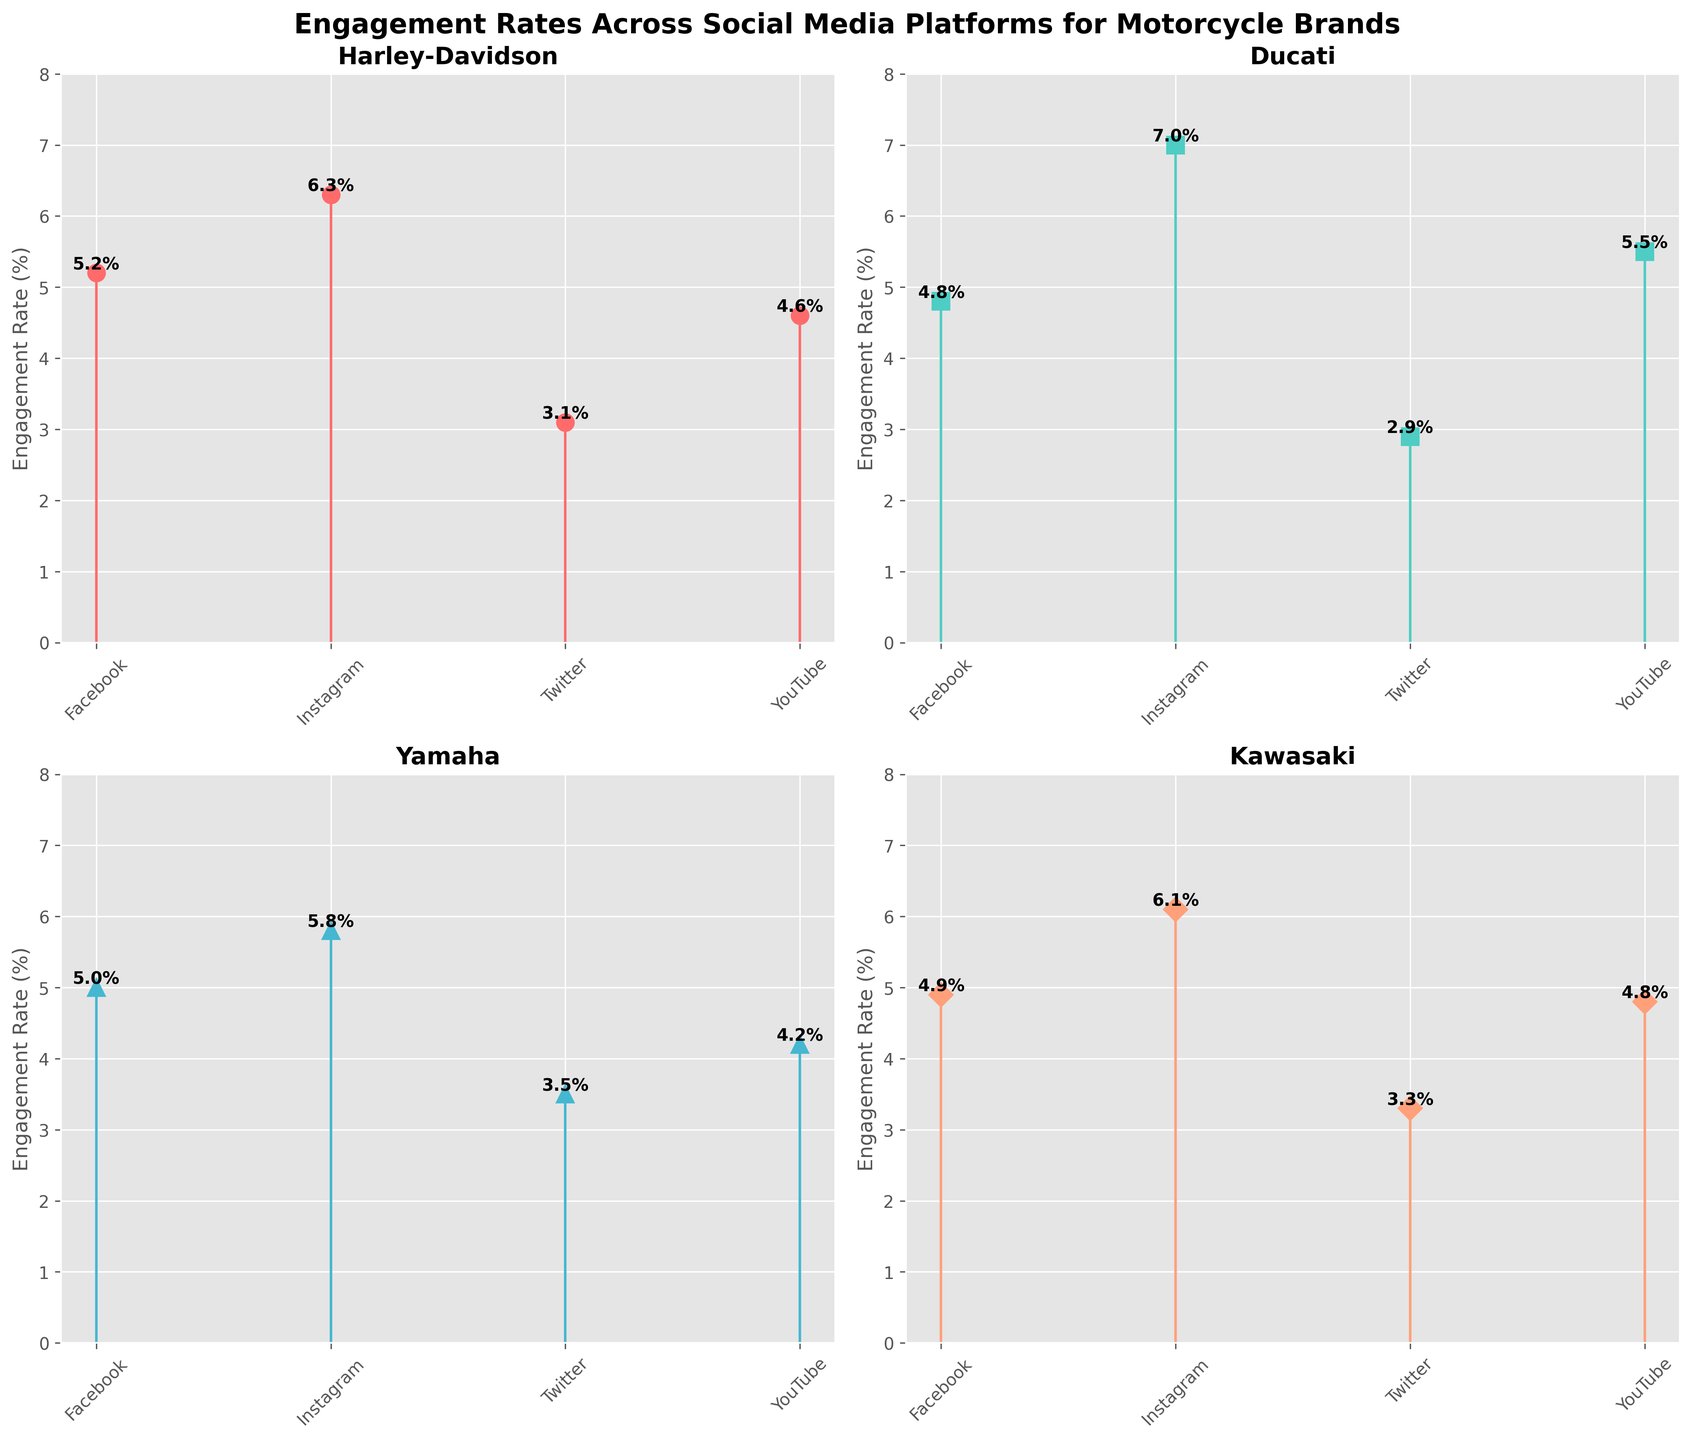What is the engagement rate of Harley-Davidson on Instagram? Look at the Harley-Davidson subplot and find the engagement rate on the Instagram stem. The Instagram stem for Harley-Davidson is labeled 6.3%.
Answer: 6.3% Which platform has the highest engagement rate for Ducati? Look at the Ducati subplot and compare the engagement rates for all four platforms (Facebook, Instagram, Twitter, YouTube). Instagram has the highest engagement rate, which is 7.0%.
Answer: Instagram How does the engagement rate on Twitter for Yamaha compare to that for Kawasaki? Look at both the Yamaha and Kawasaki subplots. Yamaha has a Twitter engagement rate of 3.5%, and Kawasaki has a Twitter engagement rate of 3.3%. Compare these values to see that Yamaha's engagement rate is higher than Kawasaki's.
Answer: Yamaha's Twitter engagement rate is higher by 0.2% Which brand has the lowest engagement rate on Facebook? Look at the Facebook engagement rates for all four brands (Harley-Davidson, Ducati, Yamaha, Kawasaki). Ducati has the lowest engagement rate on Facebook, which is 4.8%.
Answer: Ducati What is the average engagement rate for Kawasaki across all platforms? Sum the engagement rates of Kawasaki across all four platforms (Facebook, Instagram, Twitter, YouTube) and then divide by 4. The sum is 4.9 + 6.1 + 3.3 + 4.8 = 19.1. The average is 19.1 / 4 = 4.775.
Answer: 4.775 If you rank the brands by their Instagram engagement rates, which brand comes second? Identify and rank the Instagram engagement rates for all brands (Harley-Davidson: 6.3%, Ducati: 7.0%, Yamaha: 5.8%, Kawasaki: 6.1%). The second highest engagement rate is Kawasaki's 6.1%.
Answer: Kawasaki How much higher is Ducati's engagement rate on YouTube compared to Yamaha's? Look at the engagement rates on YouTube for Ducati and Yamaha. Ducati's rate is 5.5%, and Yamaha's rate is 4.2%. Subtract Yamaha's rate from Ducati's rate: 5.5% - 4.2% = 1.3%.
Answer: 1.3% Which brand has the most consistent engagement rates across the four platforms (smallest range)? Calculate the range (max - min) of engagement rates for each brand. Harley-Davidson: 6.3 - 3.1 = 3.2, Ducati: 7.0 - 2.9 = 4.1, Yamaha: 5.8 - 3.5 = 2.3, Kawasaki: 6.1 - 3.3 = 2.8. Yamaha has the smallest range of 2.3.
Answer: Yamaha What is the total engagement rate for all brands on Instagram? Sum the engagement rates on Instagram for all four brands (Harley-Davidson, Ducati, Yamaha, Kawasaki): 6.3 + 7.0 + 5.8 + 6.1 = 25.2.
Answer: 25.2 Which brand has the highest overall engagement rate on a single platform, and what is that rate? Compare the highest engagement rates on a single platform for each brand: Harley-Davidson (Instagram: 6.3%), Ducati (Instagram: 7.0%), Yamaha (Instagram: 5.8%), Kawasaki (Instagram: 6.1%). Ducati's 7.0% on Instagram is the highest.
Answer: Ducati at 7.0% 